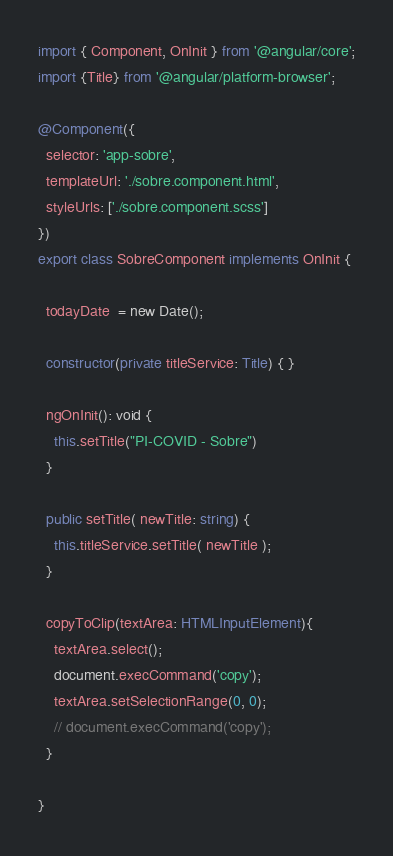<code> <loc_0><loc_0><loc_500><loc_500><_TypeScript_>import { Component, OnInit } from '@angular/core';
import {Title} from '@angular/platform-browser';

@Component({
  selector: 'app-sobre',
  templateUrl: './sobre.component.html',
  styleUrls: ['./sobre.component.scss']
})
export class SobreComponent implements OnInit {

  todayDate  = new Date();

  constructor(private titleService: Title) { }

  ngOnInit(): void {
    this.setTitle("PI-COVID - Sobre")
  }

  public setTitle( newTitle: string) {
    this.titleService.setTitle( newTitle );
  }

  copyToClip(textArea: HTMLInputElement){
    textArea.select();
    document.execCommand('copy');
    textArea.setSelectionRange(0, 0);
    // document.execCommand('copy');
  }

}
</code> 